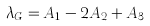<formula> <loc_0><loc_0><loc_500><loc_500>\lambda _ { G } = A _ { 1 } - 2 A _ { 2 } + A _ { 3 }</formula> 